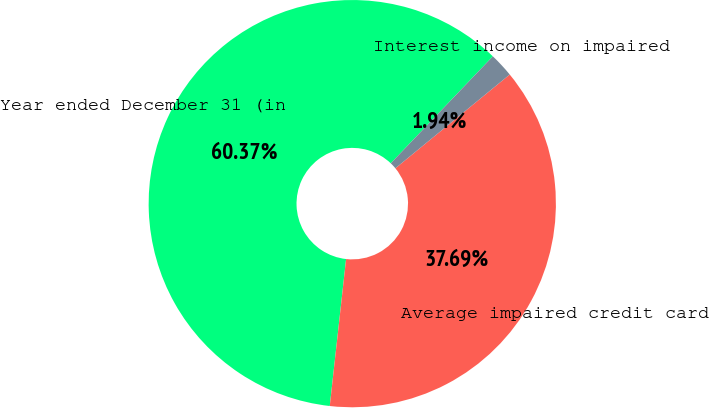<chart> <loc_0><loc_0><loc_500><loc_500><pie_chart><fcel>Year ended December 31 (in<fcel>Average impaired credit card<fcel>Interest income on impaired<nl><fcel>60.36%<fcel>37.69%<fcel>1.94%<nl></chart> 